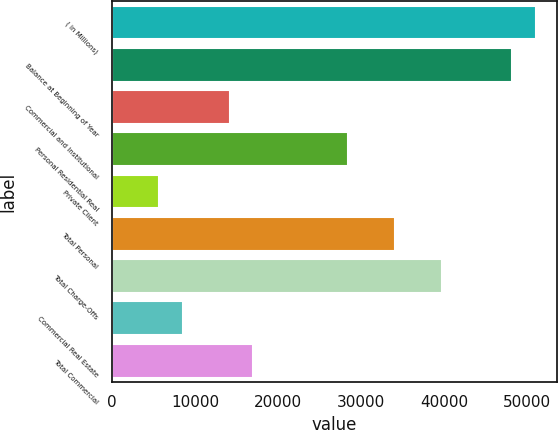<chart> <loc_0><loc_0><loc_500><loc_500><bar_chart><fcel>( in Millions)<fcel>Balance at Beginning of Year<fcel>Commercial and Institutional<fcel>Personal Residential Real<fcel>Private Client<fcel>Total Personal<fcel>Total Charge-Offs<fcel>Commercial Real Estate<fcel>Total Commercial<nl><fcel>51023.8<fcel>48189.2<fcel>14173.5<fcel>28346.7<fcel>5669.57<fcel>34016<fcel>39685.2<fcel>8504.21<fcel>17008.1<nl></chart> 